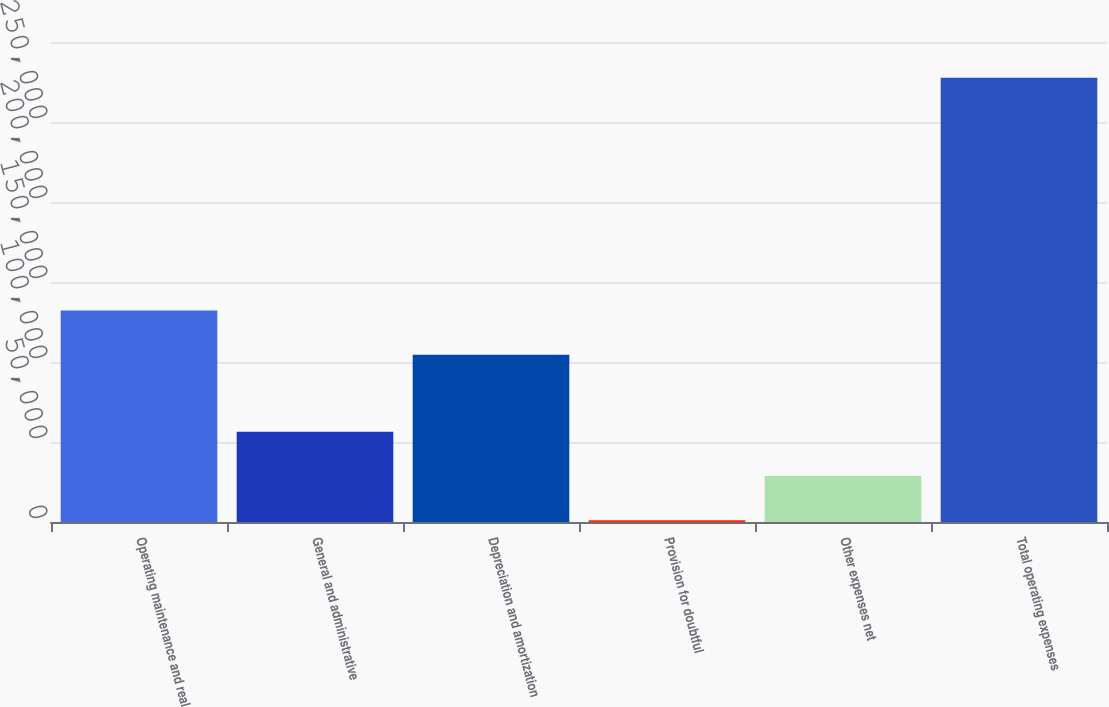Convert chart. <chart><loc_0><loc_0><loc_500><loc_500><bar_chart><fcel>Operating maintenance and real<fcel>General and administrative<fcel>Depreciation and amortization<fcel>Provision for doubtful<fcel>Other expenses net<fcel>Total operating expenses<nl><fcel>132223<fcel>56478<fcel>104569<fcel>1170<fcel>28824<fcel>277710<nl></chart> 